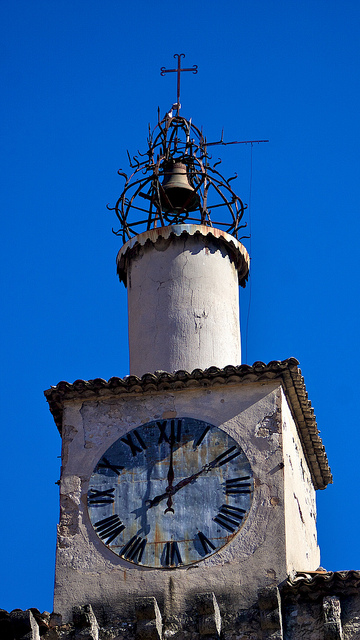Please extract the text content from this image. X III V VII 